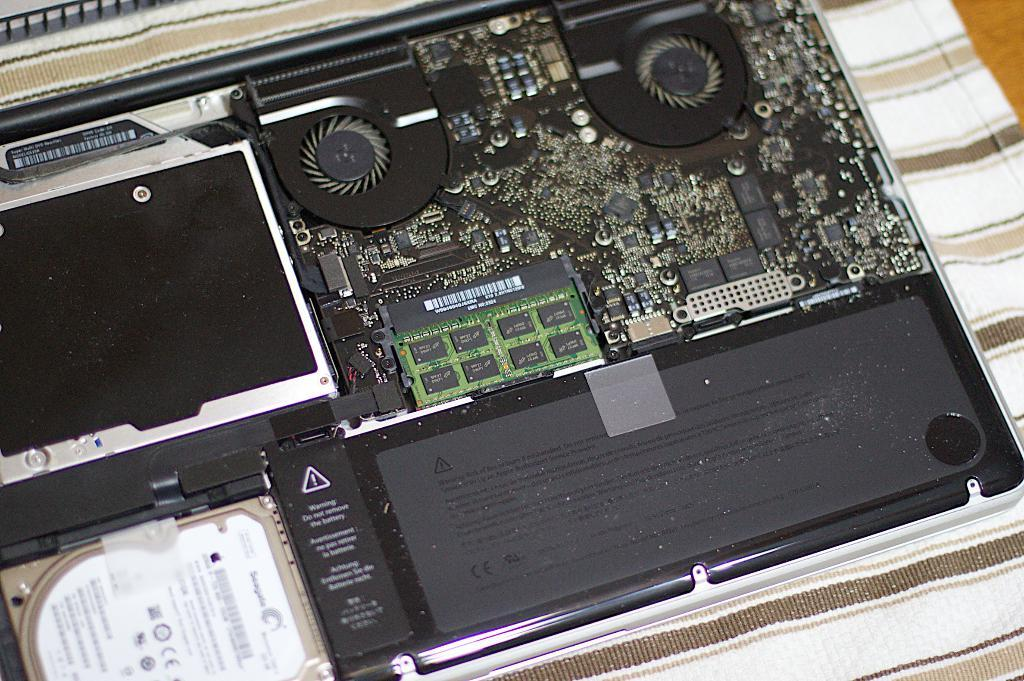Provide a one-sentence caption for the provided image. The inside of a computer contains a black plate that warns you "do not remove battery.". 